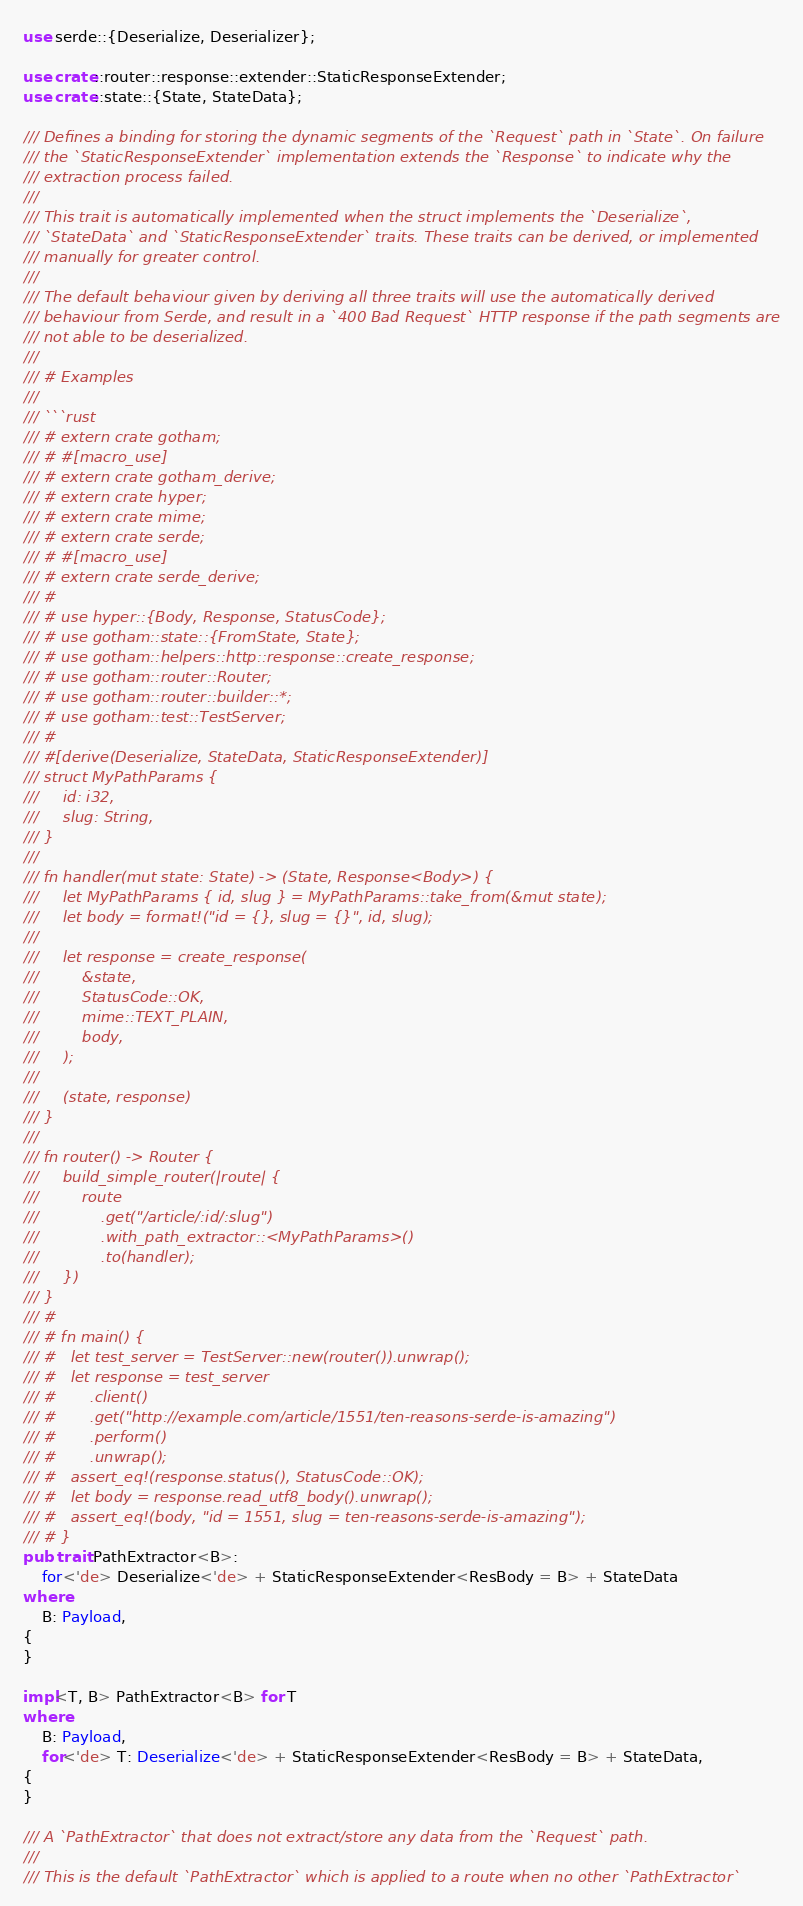Convert code to text. <code><loc_0><loc_0><loc_500><loc_500><_Rust_>use serde::{Deserialize, Deserializer};

use crate::router::response::extender::StaticResponseExtender;
use crate::state::{State, StateData};

/// Defines a binding for storing the dynamic segments of the `Request` path in `State`. On failure
/// the `StaticResponseExtender` implementation extends the `Response` to indicate why the
/// extraction process failed.
///
/// This trait is automatically implemented when the struct implements the `Deserialize`,
/// `StateData` and `StaticResponseExtender` traits. These traits can be derived, or implemented
/// manually for greater control.
///
/// The default behaviour given by deriving all three traits will use the automatically derived
/// behaviour from Serde, and result in a `400 Bad Request` HTTP response if the path segments are
/// not able to be deserialized.
///
/// # Examples
///
/// ```rust
/// # extern crate gotham;
/// # #[macro_use]
/// # extern crate gotham_derive;
/// # extern crate hyper;
/// # extern crate mime;
/// # extern crate serde;
/// # #[macro_use]
/// # extern crate serde_derive;
/// #
/// # use hyper::{Body, Response, StatusCode};
/// # use gotham::state::{FromState, State};
/// # use gotham::helpers::http::response::create_response;
/// # use gotham::router::Router;
/// # use gotham::router::builder::*;
/// # use gotham::test::TestServer;
/// #
/// #[derive(Deserialize, StateData, StaticResponseExtender)]
/// struct MyPathParams {
///     id: i32,
///     slug: String,
/// }
///
/// fn handler(mut state: State) -> (State, Response<Body>) {
///     let MyPathParams { id, slug } = MyPathParams::take_from(&mut state);
///     let body = format!("id = {}, slug = {}", id, slug);
///
///     let response = create_response(
///         &state,
///         StatusCode::OK,
///         mime::TEXT_PLAIN,
///         body,
///     );
///
///     (state, response)
/// }
///
/// fn router() -> Router {
///     build_simple_router(|route| {
///         route
///             .get("/article/:id/:slug")
///             .with_path_extractor::<MyPathParams>()
///             .to(handler);
///     })
/// }
/// #
/// # fn main() {
/// #   let test_server = TestServer::new(router()).unwrap();
/// #   let response = test_server
/// #       .client()
/// #       .get("http://example.com/article/1551/ten-reasons-serde-is-amazing")
/// #       .perform()
/// #       .unwrap();
/// #   assert_eq!(response.status(), StatusCode::OK);
/// #   let body = response.read_utf8_body().unwrap();
/// #   assert_eq!(body, "id = 1551, slug = ten-reasons-serde-is-amazing");
/// # }
pub trait PathExtractor<B>:
    for<'de> Deserialize<'de> + StaticResponseExtender<ResBody = B> + StateData
where
    B: Payload,
{
}

impl<T, B> PathExtractor<B> for T
where
    B: Payload,
    for<'de> T: Deserialize<'de> + StaticResponseExtender<ResBody = B> + StateData,
{
}

/// A `PathExtractor` that does not extract/store any data from the `Request` path.
///
/// This is the default `PathExtractor` which is applied to a route when no other `PathExtractor`</code> 